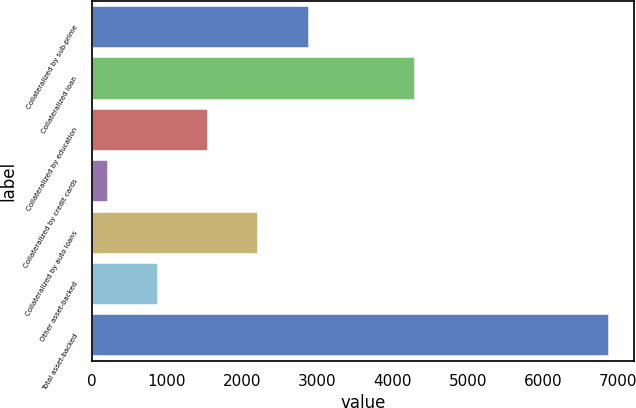<chart> <loc_0><loc_0><loc_500><loc_500><bar_chart><fcel>Collateralized by sub-prime<fcel>Collateralized loan<fcel>Collateralized by education<fcel>Collateralized by credit cards<fcel>Collateralized by auto loans<fcel>Other asset-backed<fcel>Total asset-backed<nl><fcel>2869.8<fcel>4280<fcel>1535.4<fcel>201<fcel>2202.6<fcel>868.2<fcel>6873<nl></chart> 